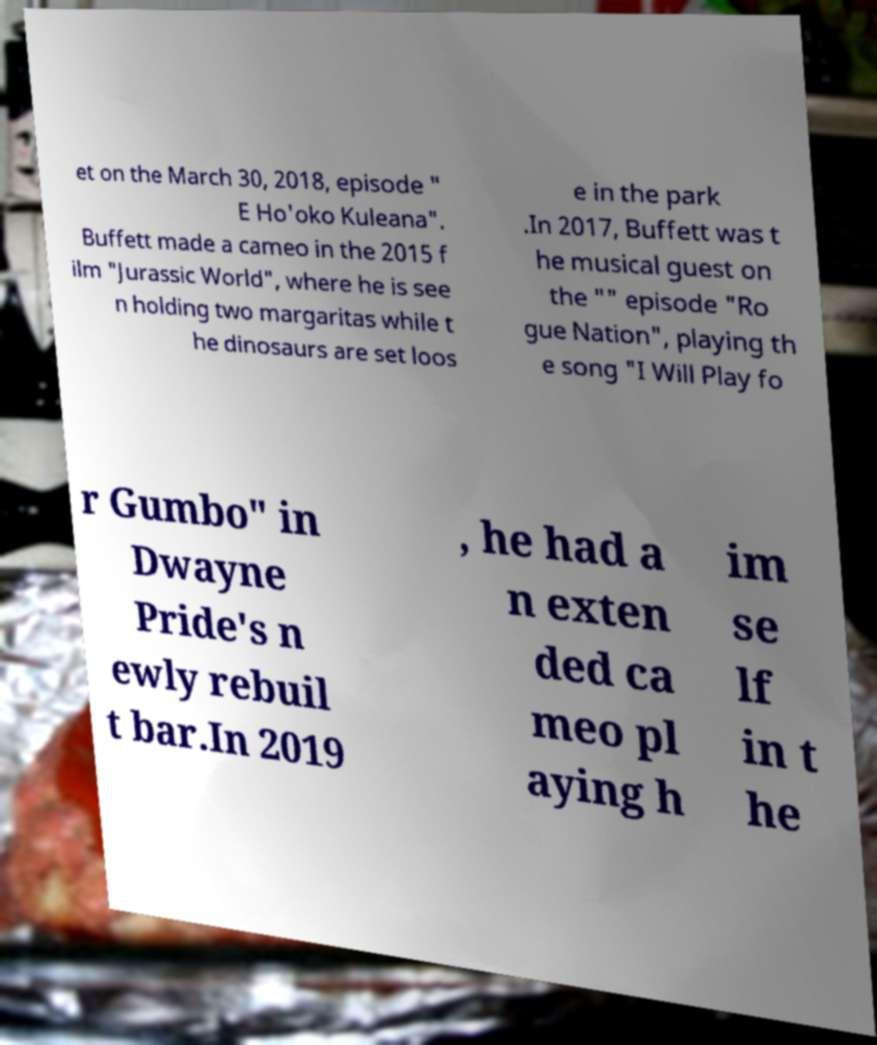Can you accurately transcribe the text from the provided image for me? et on the March 30, 2018, episode " E Ho'oko Kuleana". Buffett made a cameo in the 2015 f ilm "Jurassic World", where he is see n holding two margaritas while t he dinosaurs are set loos e in the park .In 2017, Buffett was t he musical guest on the "" episode "Ro gue Nation", playing th e song "I Will Play fo r Gumbo" in Dwayne Pride's n ewly rebuil t bar.In 2019 , he had a n exten ded ca meo pl aying h im se lf in t he 